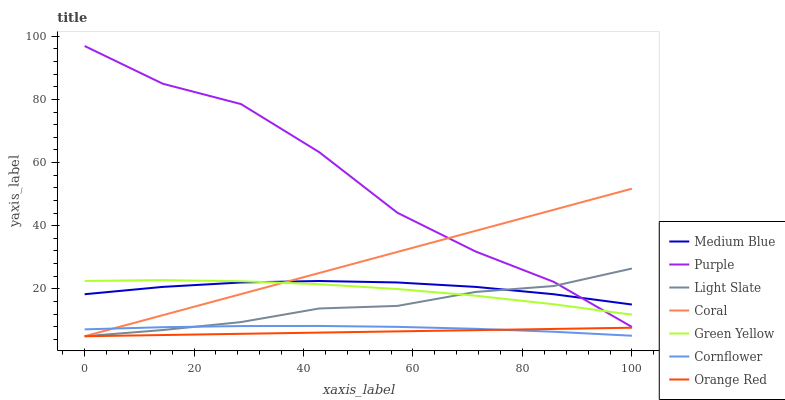Does Orange Red have the minimum area under the curve?
Answer yes or no. Yes. Does Purple have the maximum area under the curve?
Answer yes or no. Yes. Does Coral have the minimum area under the curve?
Answer yes or no. No. Does Coral have the maximum area under the curve?
Answer yes or no. No. Is Orange Red the smoothest?
Answer yes or no. Yes. Is Purple the roughest?
Answer yes or no. Yes. Is Coral the smoothest?
Answer yes or no. No. Is Coral the roughest?
Answer yes or no. No. Does Coral have the lowest value?
Answer yes or no. Yes. Does Purple have the lowest value?
Answer yes or no. No. Does Purple have the highest value?
Answer yes or no. Yes. Does Coral have the highest value?
Answer yes or no. No. Is Orange Red less than Purple?
Answer yes or no. Yes. Is Green Yellow greater than Cornflower?
Answer yes or no. Yes. Does Orange Red intersect Cornflower?
Answer yes or no. Yes. Is Orange Red less than Cornflower?
Answer yes or no. No. Is Orange Red greater than Cornflower?
Answer yes or no. No. Does Orange Red intersect Purple?
Answer yes or no. No. 